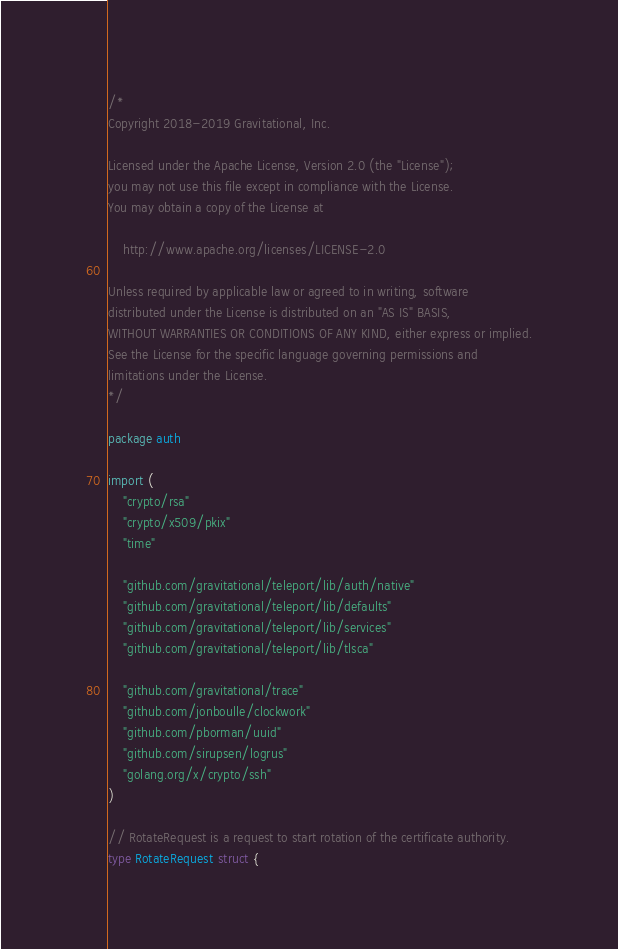<code> <loc_0><loc_0><loc_500><loc_500><_Go_>/*
Copyright 2018-2019 Gravitational, Inc.

Licensed under the Apache License, Version 2.0 (the "License");
you may not use this file except in compliance with the License.
You may obtain a copy of the License at

    http://www.apache.org/licenses/LICENSE-2.0

Unless required by applicable law or agreed to in writing, software
distributed under the License is distributed on an "AS IS" BASIS,
WITHOUT WARRANTIES OR CONDITIONS OF ANY KIND, either express or implied.
See the License for the specific language governing permissions and
limitations under the License.
*/

package auth

import (
	"crypto/rsa"
	"crypto/x509/pkix"
	"time"

	"github.com/gravitational/teleport/lib/auth/native"
	"github.com/gravitational/teleport/lib/defaults"
	"github.com/gravitational/teleport/lib/services"
	"github.com/gravitational/teleport/lib/tlsca"

	"github.com/gravitational/trace"
	"github.com/jonboulle/clockwork"
	"github.com/pborman/uuid"
	"github.com/sirupsen/logrus"
	"golang.org/x/crypto/ssh"
)

// RotateRequest is a request to start rotation of the certificate authority.
type RotateRequest struct {</code> 